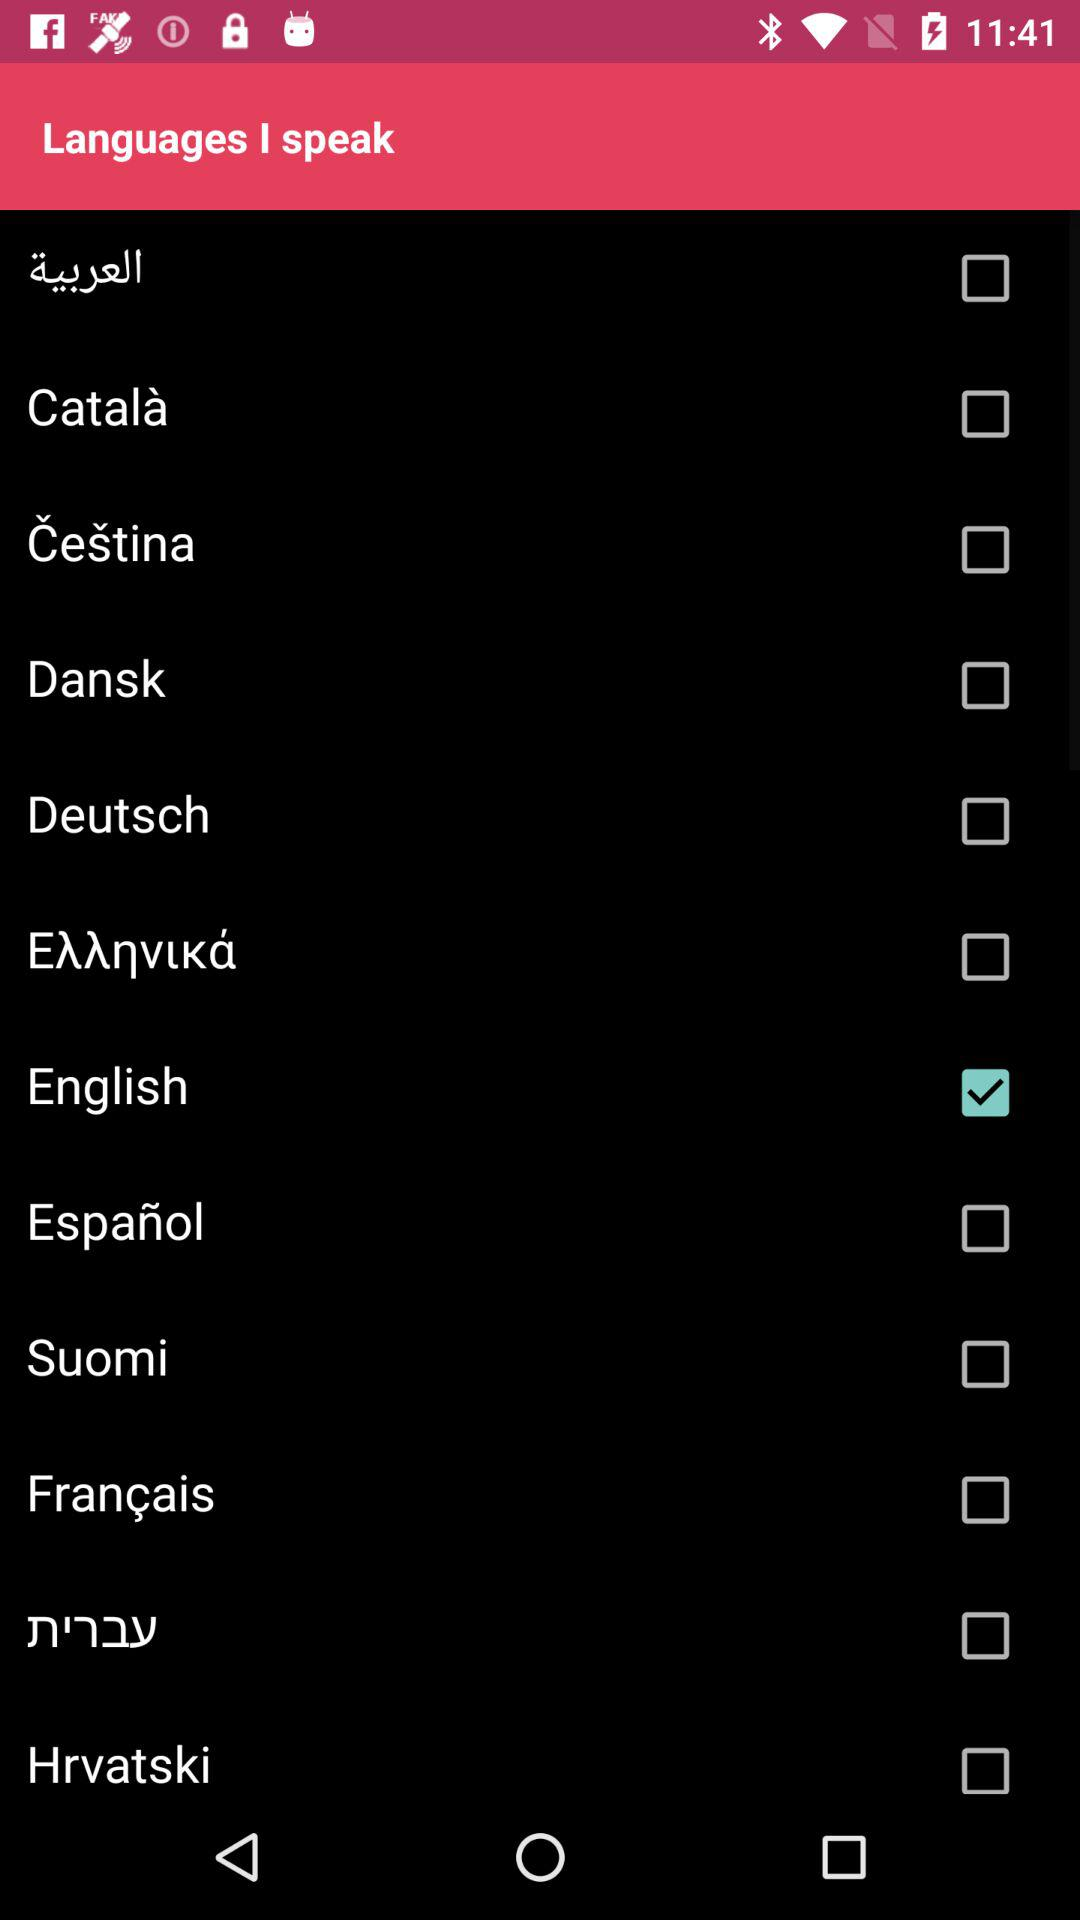Which option is selected? The selected option is English. 